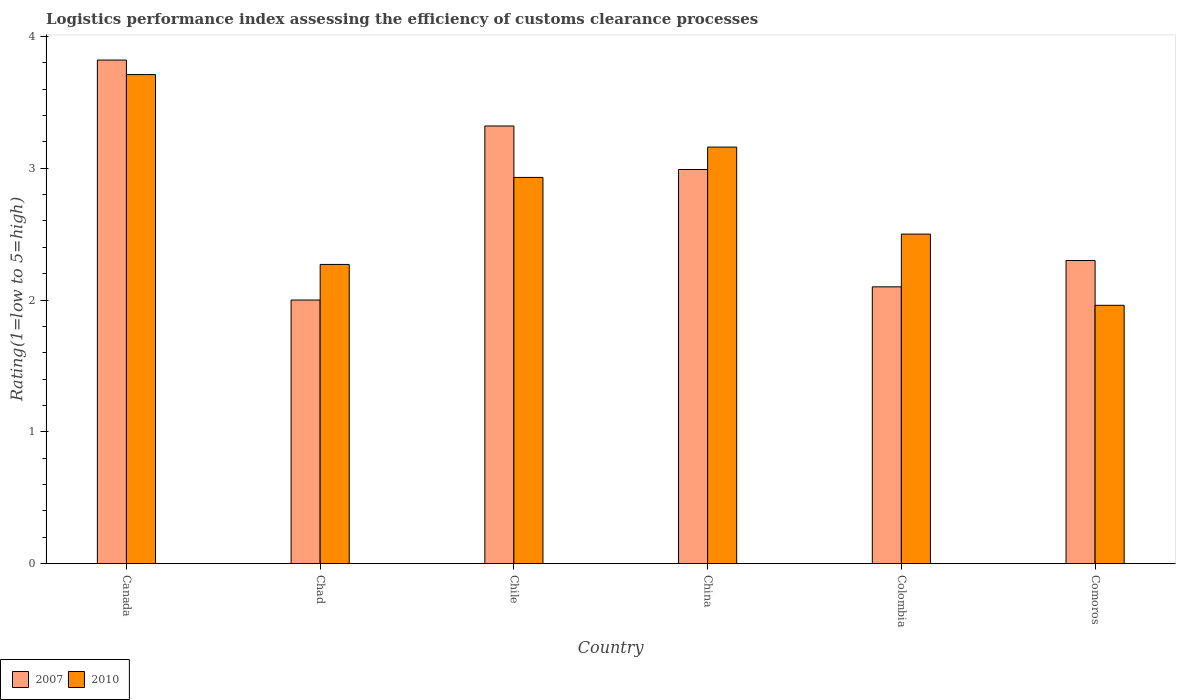How many different coloured bars are there?
Your response must be concise. 2. Are the number of bars on each tick of the X-axis equal?
Your response must be concise. Yes. How many bars are there on the 1st tick from the left?
Provide a succinct answer. 2. What is the label of the 2nd group of bars from the left?
Provide a short and direct response. Chad. In how many cases, is the number of bars for a given country not equal to the number of legend labels?
Provide a short and direct response. 0. What is the Logistic performance index in 2010 in Canada?
Ensure brevity in your answer.  3.71. Across all countries, what is the maximum Logistic performance index in 2007?
Provide a succinct answer. 3.82. Across all countries, what is the minimum Logistic performance index in 2010?
Give a very brief answer. 1.96. In which country was the Logistic performance index in 2010 minimum?
Your response must be concise. Comoros. What is the total Logistic performance index in 2010 in the graph?
Your answer should be very brief. 16.53. What is the difference between the Logistic performance index in 2010 in Chad and that in China?
Your answer should be very brief. -0.89. What is the difference between the Logistic performance index in 2010 in China and the Logistic performance index in 2007 in Canada?
Offer a very short reply. -0.66. What is the average Logistic performance index in 2007 per country?
Provide a short and direct response. 2.76. What is the difference between the Logistic performance index of/in 2010 and Logistic performance index of/in 2007 in Colombia?
Provide a succinct answer. 0.4. In how many countries, is the Logistic performance index in 2007 greater than 3?
Offer a terse response. 2. What is the ratio of the Logistic performance index in 2007 in Canada to that in Comoros?
Offer a terse response. 1.66. Is the difference between the Logistic performance index in 2010 in Colombia and Comoros greater than the difference between the Logistic performance index in 2007 in Colombia and Comoros?
Your answer should be very brief. Yes. What is the difference between the highest and the second highest Logistic performance index in 2007?
Your answer should be compact. 0.33. What is the difference between the highest and the lowest Logistic performance index in 2007?
Provide a succinct answer. 1.82. In how many countries, is the Logistic performance index in 2007 greater than the average Logistic performance index in 2007 taken over all countries?
Your response must be concise. 3. How many bars are there?
Provide a succinct answer. 12. Are all the bars in the graph horizontal?
Give a very brief answer. No. How many countries are there in the graph?
Give a very brief answer. 6. Does the graph contain grids?
Keep it short and to the point. No. Where does the legend appear in the graph?
Provide a succinct answer. Bottom left. What is the title of the graph?
Provide a short and direct response. Logistics performance index assessing the efficiency of customs clearance processes. What is the label or title of the Y-axis?
Keep it short and to the point. Rating(1=low to 5=high). What is the Rating(1=low to 5=high) in 2007 in Canada?
Your response must be concise. 3.82. What is the Rating(1=low to 5=high) in 2010 in Canada?
Provide a succinct answer. 3.71. What is the Rating(1=low to 5=high) of 2007 in Chad?
Provide a succinct answer. 2. What is the Rating(1=low to 5=high) of 2010 in Chad?
Ensure brevity in your answer.  2.27. What is the Rating(1=low to 5=high) in 2007 in Chile?
Provide a short and direct response. 3.32. What is the Rating(1=low to 5=high) in 2010 in Chile?
Ensure brevity in your answer.  2.93. What is the Rating(1=low to 5=high) in 2007 in China?
Provide a succinct answer. 2.99. What is the Rating(1=low to 5=high) in 2010 in China?
Provide a succinct answer. 3.16. What is the Rating(1=low to 5=high) in 2007 in Colombia?
Your answer should be compact. 2.1. What is the Rating(1=low to 5=high) of 2010 in Colombia?
Your answer should be compact. 2.5. What is the Rating(1=low to 5=high) in 2007 in Comoros?
Offer a terse response. 2.3. What is the Rating(1=low to 5=high) of 2010 in Comoros?
Your response must be concise. 1.96. Across all countries, what is the maximum Rating(1=low to 5=high) in 2007?
Provide a short and direct response. 3.82. Across all countries, what is the maximum Rating(1=low to 5=high) in 2010?
Offer a very short reply. 3.71. Across all countries, what is the minimum Rating(1=low to 5=high) in 2010?
Make the answer very short. 1.96. What is the total Rating(1=low to 5=high) of 2007 in the graph?
Make the answer very short. 16.53. What is the total Rating(1=low to 5=high) in 2010 in the graph?
Offer a terse response. 16.53. What is the difference between the Rating(1=low to 5=high) of 2007 in Canada and that in Chad?
Offer a very short reply. 1.82. What is the difference between the Rating(1=low to 5=high) in 2010 in Canada and that in Chad?
Your answer should be very brief. 1.44. What is the difference between the Rating(1=low to 5=high) of 2007 in Canada and that in Chile?
Make the answer very short. 0.5. What is the difference between the Rating(1=low to 5=high) of 2010 in Canada and that in Chile?
Make the answer very short. 0.78. What is the difference between the Rating(1=low to 5=high) of 2007 in Canada and that in China?
Make the answer very short. 0.83. What is the difference between the Rating(1=low to 5=high) of 2010 in Canada and that in China?
Your response must be concise. 0.55. What is the difference between the Rating(1=low to 5=high) of 2007 in Canada and that in Colombia?
Ensure brevity in your answer.  1.72. What is the difference between the Rating(1=low to 5=high) in 2010 in Canada and that in Colombia?
Give a very brief answer. 1.21. What is the difference between the Rating(1=low to 5=high) in 2007 in Canada and that in Comoros?
Your answer should be compact. 1.52. What is the difference between the Rating(1=low to 5=high) in 2007 in Chad and that in Chile?
Provide a succinct answer. -1.32. What is the difference between the Rating(1=low to 5=high) in 2010 in Chad and that in Chile?
Offer a terse response. -0.66. What is the difference between the Rating(1=low to 5=high) in 2007 in Chad and that in China?
Provide a succinct answer. -0.99. What is the difference between the Rating(1=low to 5=high) in 2010 in Chad and that in China?
Keep it short and to the point. -0.89. What is the difference between the Rating(1=low to 5=high) of 2007 in Chad and that in Colombia?
Your answer should be compact. -0.1. What is the difference between the Rating(1=low to 5=high) in 2010 in Chad and that in Colombia?
Provide a succinct answer. -0.23. What is the difference between the Rating(1=low to 5=high) in 2010 in Chad and that in Comoros?
Offer a very short reply. 0.31. What is the difference between the Rating(1=low to 5=high) in 2007 in Chile and that in China?
Your response must be concise. 0.33. What is the difference between the Rating(1=low to 5=high) in 2010 in Chile and that in China?
Keep it short and to the point. -0.23. What is the difference between the Rating(1=low to 5=high) in 2007 in Chile and that in Colombia?
Keep it short and to the point. 1.22. What is the difference between the Rating(1=low to 5=high) in 2010 in Chile and that in Colombia?
Provide a short and direct response. 0.43. What is the difference between the Rating(1=low to 5=high) of 2007 in China and that in Colombia?
Provide a succinct answer. 0.89. What is the difference between the Rating(1=low to 5=high) of 2010 in China and that in Colombia?
Your response must be concise. 0.66. What is the difference between the Rating(1=low to 5=high) of 2007 in China and that in Comoros?
Ensure brevity in your answer.  0.69. What is the difference between the Rating(1=low to 5=high) in 2010 in Colombia and that in Comoros?
Keep it short and to the point. 0.54. What is the difference between the Rating(1=low to 5=high) of 2007 in Canada and the Rating(1=low to 5=high) of 2010 in Chad?
Your answer should be very brief. 1.55. What is the difference between the Rating(1=low to 5=high) of 2007 in Canada and the Rating(1=low to 5=high) of 2010 in Chile?
Your answer should be compact. 0.89. What is the difference between the Rating(1=low to 5=high) of 2007 in Canada and the Rating(1=low to 5=high) of 2010 in China?
Your answer should be compact. 0.66. What is the difference between the Rating(1=low to 5=high) of 2007 in Canada and the Rating(1=low to 5=high) of 2010 in Colombia?
Offer a terse response. 1.32. What is the difference between the Rating(1=low to 5=high) in 2007 in Canada and the Rating(1=low to 5=high) in 2010 in Comoros?
Offer a terse response. 1.86. What is the difference between the Rating(1=low to 5=high) in 2007 in Chad and the Rating(1=low to 5=high) in 2010 in Chile?
Make the answer very short. -0.93. What is the difference between the Rating(1=low to 5=high) in 2007 in Chad and the Rating(1=low to 5=high) in 2010 in China?
Offer a very short reply. -1.16. What is the difference between the Rating(1=low to 5=high) in 2007 in Chad and the Rating(1=low to 5=high) in 2010 in Comoros?
Offer a very short reply. 0.04. What is the difference between the Rating(1=low to 5=high) of 2007 in Chile and the Rating(1=low to 5=high) of 2010 in China?
Your answer should be very brief. 0.16. What is the difference between the Rating(1=low to 5=high) in 2007 in Chile and the Rating(1=low to 5=high) in 2010 in Colombia?
Provide a short and direct response. 0.82. What is the difference between the Rating(1=low to 5=high) of 2007 in Chile and the Rating(1=low to 5=high) of 2010 in Comoros?
Provide a short and direct response. 1.36. What is the difference between the Rating(1=low to 5=high) of 2007 in China and the Rating(1=low to 5=high) of 2010 in Colombia?
Offer a very short reply. 0.49. What is the difference between the Rating(1=low to 5=high) of 2007 in China and the Rating(1=low to 5=high) of 2010 in Comoros?
Your answer should be compact. 1.03. What is the difference between the Rating(1=low to 5=high) in 2007 in Colombia and the Rating(1=low to 5=high) in 2010 in Comoros?
Provide a short and direct response. 0.14. What is the average Rating(1=low to 5=high) in 2007 per country?
Your answer should be compact. 2.75. What is the average Rating(1=low to 5=high) in 2010 per country?
Offer a very short reply. 2.75. What is the difference between the Rating(1=low to 5=high) of 2007 and Rating(1=low to 5=high) of 2010 in Canada?
Ensure brevity in your answer.  0.11. What is the difference between the Rating(1=low to 5=high) in 2007 and Rating(1=low to 5=high) in 2010 in Chad?
Provide a succinct answer. -0.27. What is the difference between the Rating(1=low to 5=high) of 2007 and Rating(1=low to 5=high) of 2010 in Chile?
Give a very brief answer. 0.39. What is the difference between the Rating(1=low to 5=high) of 2007 and Rating(1=low to 5=high) of 2010 in China?
Your response must be concise. -0.17. What is the difference between the Rating(1=low to 5=high) in 2007 and Rating(1=low to 5=high) in 2010 in Colombia?
Provide a short and direct response. -0.4. What is the difference between the Rating(1=low to 5=high) in 2007 and Rating(1=low to 5=high) in 2010 in Comoros?
Keep it short and to the point. 0.34. What is the ratio of the Rating(1=low to 5=high) of 2007 in Canada to that in Chad?
Make the answer very short. 1.91. What is the ratio of the Rating(1=low to 5=high) in 2010 in Canada to that in Chad?
Provide a succinct answer. 1.63. What is the ratio of the Rating(1=low to 5=high) in 2007 in Canada to that in Chile?
Offer a very short reply. 1.15. What is the ratio of the Rating(1=low to 5=high) of 2010 in Canada to that in Chile?
Your response must be concise. 1.27. What is the ratio of the Rating(1=low to 5=high) of 2007 in Canada to that in China?
Make the answer very short. 1.28. What is the ratio of the Rating(1=low to 5=high) of 2010 in Canada to that in China?
Provide a succinct answer. 1.17. What is the ratio of the Rating(1=low to 5=high) in 2007 in Canada to that in Colombia?
Make the answer very short. 1.82. What is the ratio of the Rating(1=low to 5=high) in 2010 in Canada to that in Colombia?
Ensure brevity in your answer.  1.48. What is the ratio of the Rating(1=low to 5=high) of 2007 in Canada to that in Comoros?
Provide a succinct answer. 1.66. What is the ratio of the Rating(1=low to 5=high) of 2010 in Canada to that in Comoros?
Make the answer very short. 1.89. What is the ratio of the Rating(1=low to 5=high) of 2007 in Chad to that in Chile?
Your answer should be compact. 0.6. What is the ratio of the Rating(1=low to 5=high) of 2010 in Chad to that in Chile?
Make the answer very short. 0.77. What is the ratio of the Rating(1=low to 5=high) in 2007 in Chad to that in China?
Offer a very short reply. 0.67. What is the ratio of the Rating(1=low to 5=high) in 2010 in Chad to that in China?
Your answer should be compact. 0.72. What is the ratio of the Rating(1=low to 5=high) in 2010 in Chad to that in Colombia?
Provide a short and direct response. 0.91. What is the ratio of the Rating(1=low to 5=high) of 2007 in Chad to that in Comoros?
Your answer should be compact. 0.87. What is the ratio of the Rating(1=low to 5=high) in 2010 in Chad to that in Comoros?
Provide a short and direct response. 1.16. What is the ratio of the Rating(1=low to 5=high) of 2007 in Chile to that in China?
Keep it short and to the point. 1.11. What is the ratio of the Rating(1=low to 5=high) in 2010 in Chile to that in China?
Your answer should be very brief. 0.93. What is the ratio of the Rating(1=low to 5=high) in 2007 in Chile to that in Colombia?
Provide a short and direct response. 1.58. What is the ratio of the Rating(1=low to 5=high) in 2010 in Chile to that in Colombia?
Your response must be concise. 1.17. What is the ratio of the Rating(1=low to 5=high) in 2007 in Chile to that in Comoros?
Provide a short and direct response. 1.44. What is the ratio of the Rating(1=low to 5=high) in 2010 in Chile to that in Comoros?
Your answer should be compact. 1.49. What is the ratio of the Rating(1=low to 5=high) in 2007 in China to that in Colombia?
Your answer should be compact. 1.42. What is the ratio of the Rating(1=low to 5=high) in 2010 in China to that in Colombia?
Ensure brevity in your answer.  1.26. What is the ratio of the Rating(1=low to 5=high) in 2007 in China to that in Comoros?
Provide a short and direct response. 1.3. What is the ratio of the Rating(1=low to 5=high) in 2010 in China to that in Comoros?
Offer a very short reply. 1.61. What is the ratio of the Rating(1=low to 5=high) of 2007 in Colombia to that in Comoros?
Ensure brevity in your answer.  0.91. What is the ratio of the Rating(1=low to 5=high) of 2010 in Colombia to that in Comoros?
Ensure brevity in your answer.  1.28. What is the difference between the highest and the second highest Rating(1=low to 5=high) of 2007?
Offer a very short reply. 0.5. What is the difference between the highest and the second highest Rating(1=low to 5=high) of 2010?
Your response must be concise. 0.55. What is the difference between the highest and the lowest Rating(1=low to 5=high) of 2007?
Make the answer very short. 1.82. 